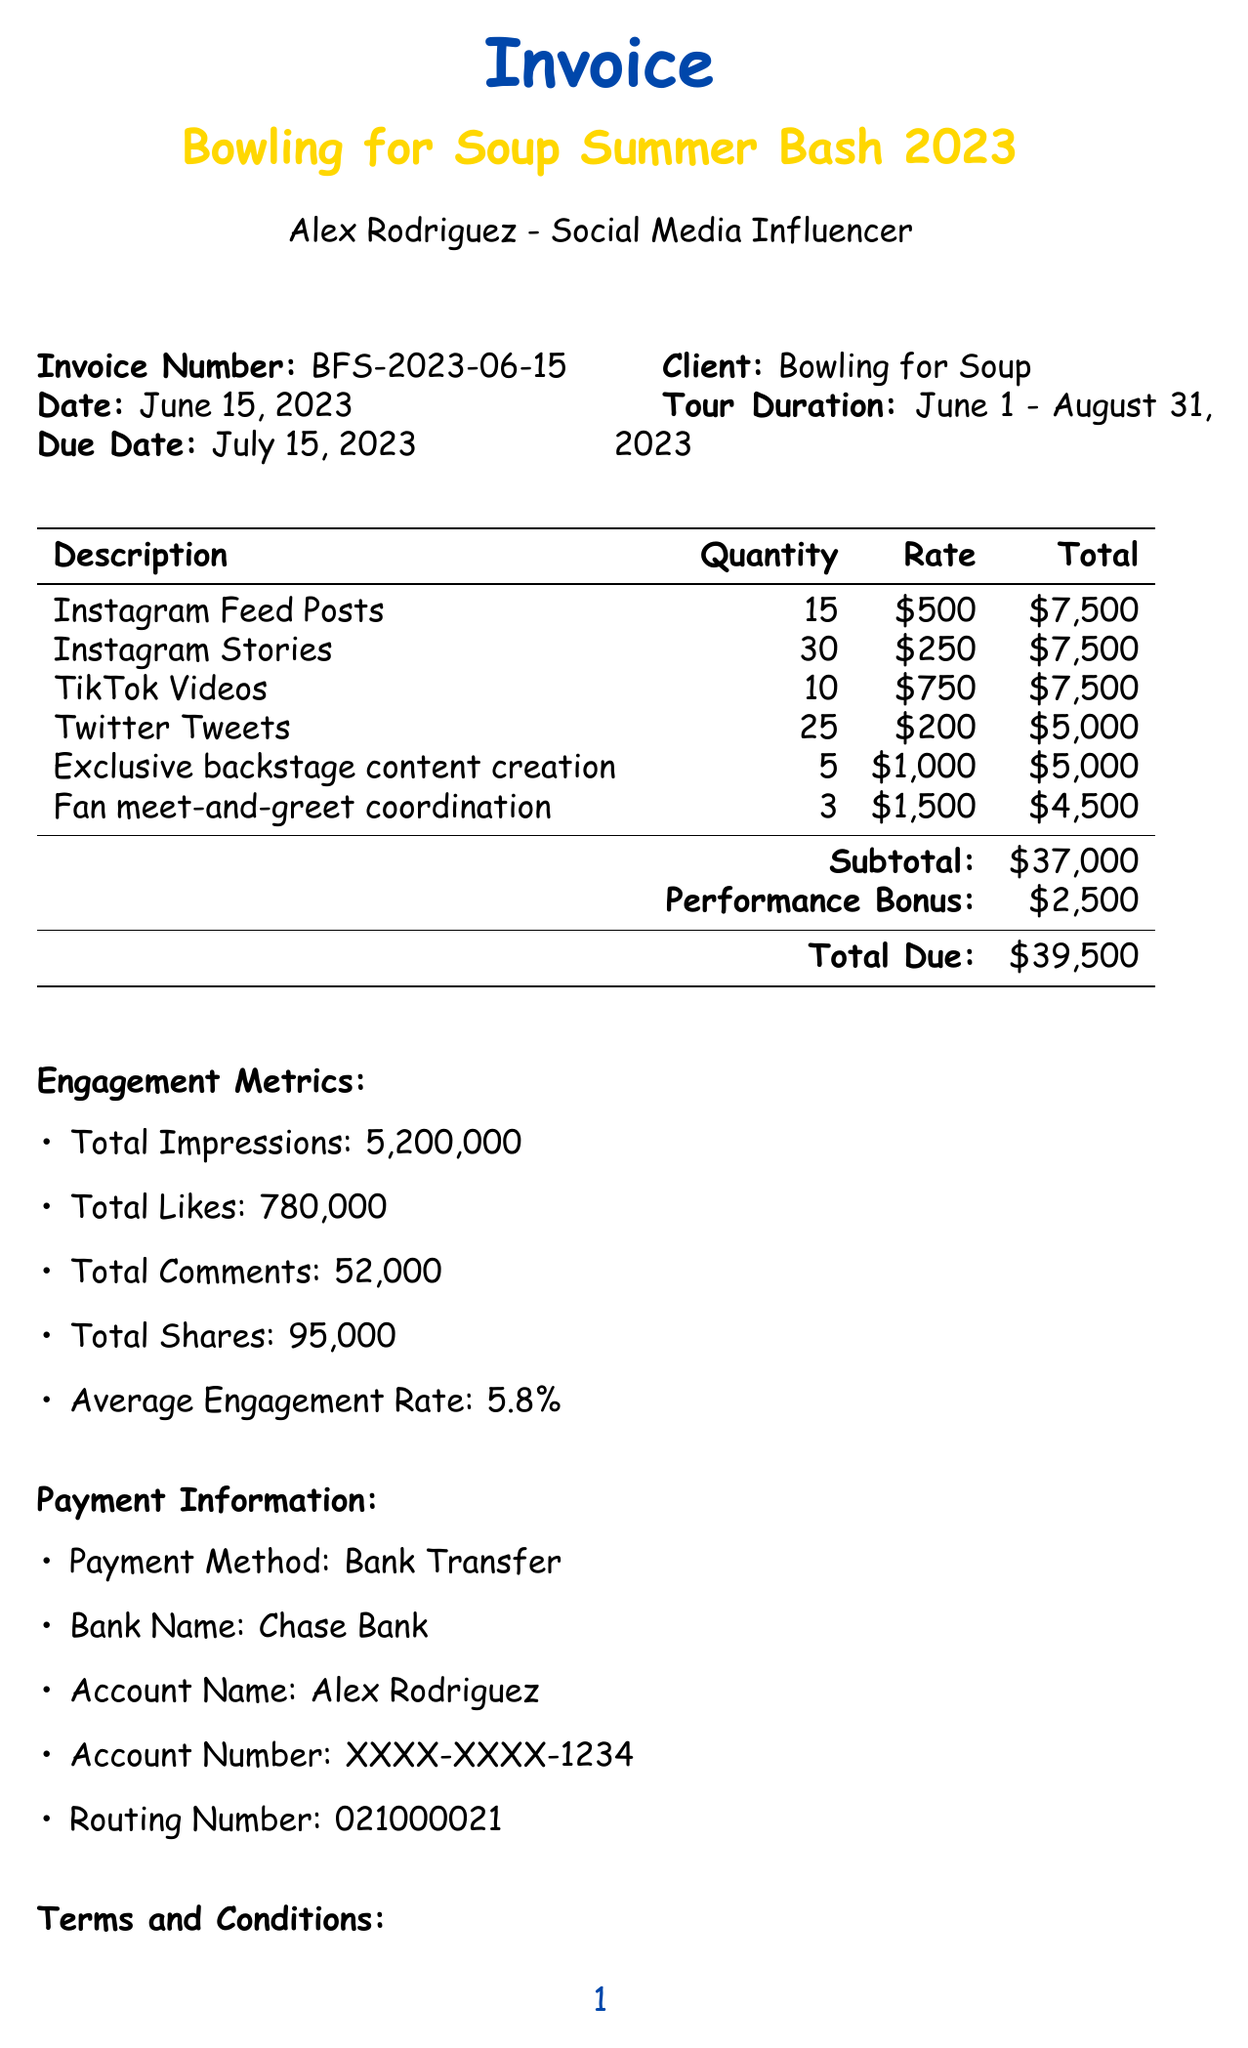What is the invoice number? The invoice number is a unique identifier for the document, which is mentioned at the top.
Answer: BFS-2023-06-15 What is the total due amount? The total due amount is the final sum that needs to be paid and is listed in the summary section.
Answer: $42,000 How many TikTok videos were posted? The quantity of TikTok videos is specified in the breakdown of social media posts.
Answer: 10 What is the performance bonus for? The performance bonus is awarded for exceeding a certain metric mentioned in the document.
Answer: Exceeding 5 million impressions What is the average engagement rate? The average engagement rate reflects the effectiveness of the posts and is stated in the engagement metrics.
Answer: 5.8% What is the due date for this invoice? The due date indicates when the payment needs to be made and is specified in the invoice details.
Answer: July 15, 2023 What are the payment terms? The payment terms outline the conditions under which payment is to be made and are detailed in the terms and conditions section.
Answer: Payment is due within 30 days of invoice date How many Instagram stories were posted? The number of Instagram stories is part of the breakdown of social media promotions provided in the document.
Answer: 30 What is the bank name listed for payment? The bank name indicates where the payment should be transferred, as per the payment information.
Answer: Chase Bank 